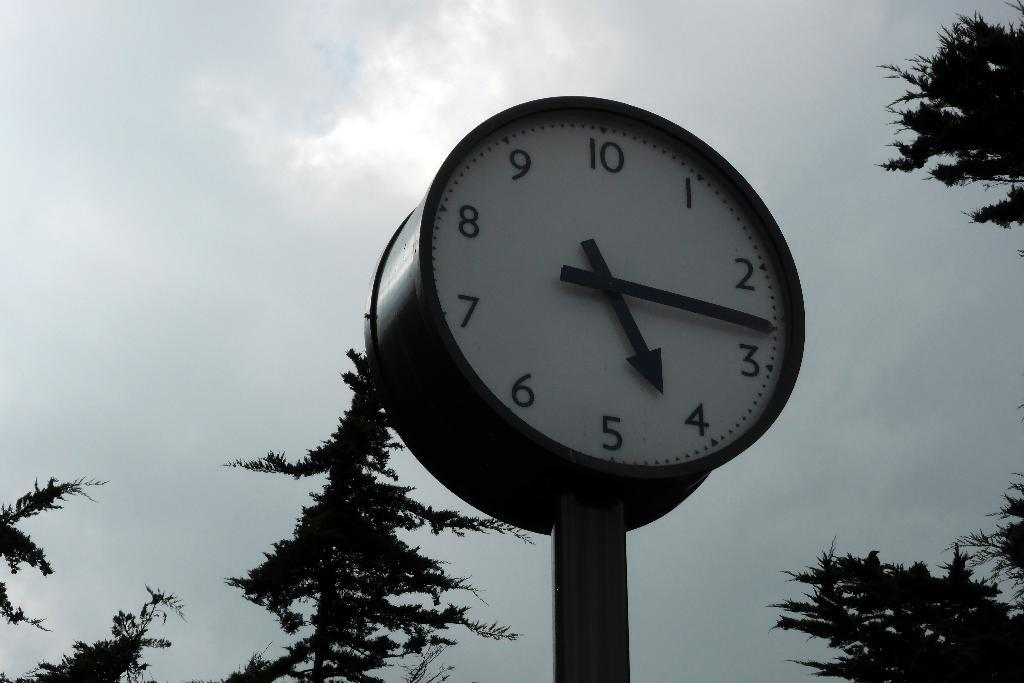What object in the image can be used to tell time? There is a clock in the image that can be used to tell time. What type of natural elements can be seen in the image? There are trees in the image. What is visible in the background of the image? The sky is visible in the background of the image. What type of vegetable is growing on the clock in the image? There are no vegetables present in the image, and the clock is not a growing medium for plants. 